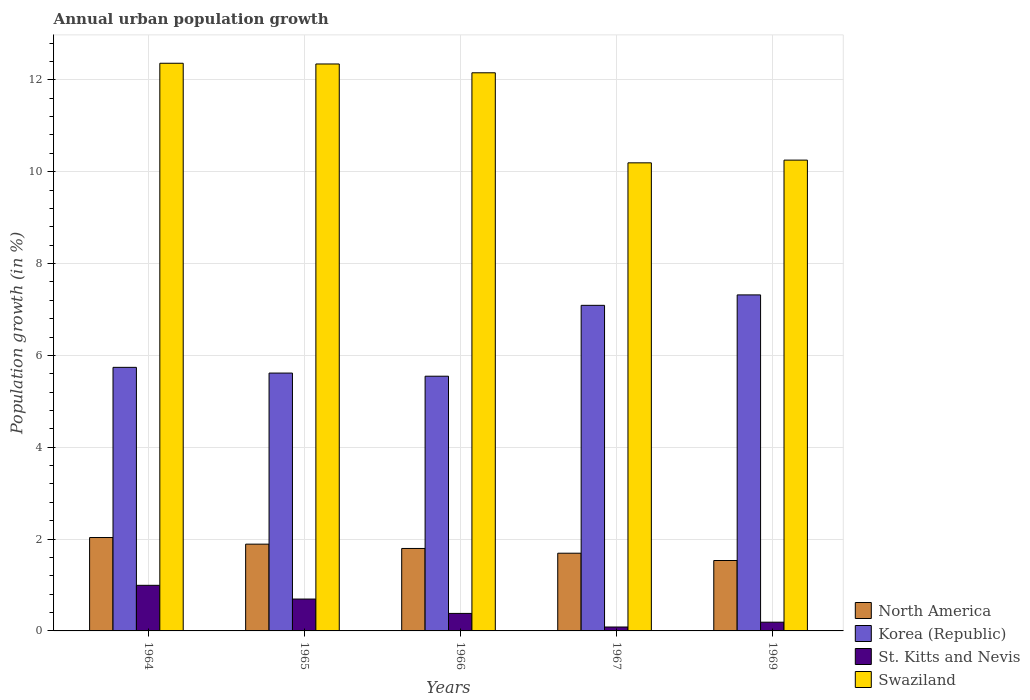How many groups of bars are there?
Ensure brevity in your answer.  5. How many bars are there on the 3rd tick from the right?
Your answer should be very brief. 4. What is the label of the 3rd group of bars from the left?
Offer a terse response. 1966. What is the percentage of urban population growth in St. Kitts and Nevis in 1966?
Ensure brevity in your answer.  0.38. Across all years, what is the maximum percentage of urban population growth in Swaziland?
Make the answer very short. 12.36. Across all years, what is the minimum percentage of urban population growth in North America?
Provide a succinct answer. 1.53. In which year was the percentage of urban population growth in St. Kitts and Nevis maximum?
Offer a terse response. 1964. In which year was the percentage of urban population growth in Swaziland minimum?
Give a very brief answer. 1967. What is the total percentage of urban population growth in North America in the graph?
Your answer should be compact. 8.94. What is the difference between the percentage of urban population growth in Swaziland in 1965 and that in 1969?
Your response must be concise. 2.09. What is the difference between the percentage of urban population growth in Swaziland in 1965 and the percentage of urban population growth in North America in 1967?
Your answer should be very brief. 10.65. What is the average percentage of urban population growth in North America per year?
Your answer should be compact. 1.79. In the year 1964, what is the difference between the percentage of urban population growth in Korea (Republic) and percentage of urban population growth in St. Kitts and Nevis?
Give a very brief answer. 4.75. What is the ratio of the percentage of urban population growth in St. Kitts and Nevis in 1967 to that in 1969?
Your response must be concise. 0.45. Is the difference between the percentage of urban population growth in Korea (Republic) in 1965 and 1966 greater than the difference between the percentage of urban population growth in St. Kitts and Nevis in 1965 and 1966?
Offer a terse response. No. What is the difference between the highest and the second highest percentage of urban population growth in Korea (Republic)?
Ensure brevity in your answer.  0.23. What is the difference between the highest and the lowest percentage of urban population growth in Korea (Republic)?
Offer a terse response. 1.77. Is the sum of the percentage of urban population growth in Swaziland in 1966 and 1969 greater than the maximum percentage of urban population growth in North America across all years?
Provide a short and direct response. Yes. Is it the case that in every year, the sum of the percentage of urban population growth in St. Kitts and Nevis and percentage of urban population growth in Swaziland is greater than the sum of percentage of urban population growth in Korea (Republic) and percentage of urban population growth in North America?
Keep it short and to the point. Yes. Is it the case that in every year, the sum of the percentage of urban population growth in Korea (Republic) and percentage of urban population growth in Swaziland is greater than the percentage of urban population growth in North America?
Give a very brief answer. Yes. Are all the bars in the graph horizontal?
Offer a very short reply. No. How many years are there in the graph?
Offer a very short reply. 5. Does the graph contain any zero values?
Give a very brief answer. No. Does the graph contain grids?
Your response must be concise. Yes. Where does the legend appear in the graph?
Provide a succinct answer. Bottom right. What is the title of the graph?
Your answer should be very brief. Annual urban population growth. What is the label or title of the Y-axis?
Provide a succinct answer. Population growth (in %). What is the Population growth (in %) in North America in 1964?
Make the answer very short. 2.03. What is the Population growth (in %) in Korea (Republic) in 1964?
Provide a succinct answer. 5.74. What is the Population growth (in %) in St. Kitts and Nevis in 1964?
Keep it short and to the point. 0.99. What is the Population growth (in %) of Swaziland in 1964?
Provide a short and direct response. 12.36. What is the Population growth (in %) in North America in 1965?
Your response must be concise. 1.89. What is the Population growth (in %) of Korea (Republic) in 1965?
Give a very brief answer. 5.62. What is the Population growth (in %) of St. Kitts and Nevis in 1965?
Offer a very short reply. 0.69. What is the Population growth (in %) of Swaziland in 1965?
Offer a terse response. 12.35. What is the Population growth (in %) of North America in 1966?
Your answer should be compact. 1.8. What is the Population growth (in %) of Korea (Republic) in 1966?
Offer a terse response. 5.55. What is the Population growth (in %) in St. Kitts and Nevis in 1966?
Give a very brief answer. 0.38. What is the Population growth (in %) of Swaziland in 1966?
Your answer should be compact. 12.15. What is the Population growth (in %) of North America in 1967?
Offer a terse response. 1.69. What is the Population growth (in %) in Korea (Republic) in 1967?
Your answer should be very brief. 7.09. What is the Population growth (in %) in St. Kitts and Nevis in 1967?
Your answer should be very brief. 0.09. What is the Population growth (in %) in Swaziland in 1967?
Your answer should be very brief. 10.19. What is the Population growth (in %) in North America in 1969?
Your answer should be very brief. 1.53. What is the Population growth (in %) in Korea (Republic) in 1969?
Your response must be concise. 7.32. What is the Population growth (in %) of St. Kitts and Nevis in 1969?
Provide a succinct answer. 0.19. What is the Population growth (in %) in Swaziland in 1969?
Offer a very short reply. 10.25. Across all years, what is the maximum Population growth (in %) of North America?
Your answer should be compact. 2.03. Across all years, what is the maximum Population growth (in %) in Korea (Republic)?
Offer a terse response. 7.32. Across all years, what is the maximum Population growth (in %) of St. Kitts and Nevis?
Offer a terse response. 0.99. Across all years, what is the maximum Population growth (in %) in Swaziland?
Provide a succinct answer. 12.36. Across all years, what is the minimum Population growth (in %) in North America?
Give a very brief answer. 1.53. Across all years, what is the minimum Population growth (in %) of Korea (Republic)?
Make the answer very short. 5.55. Across all years, what is the minimum Population growth (in %) in St. Kitts and Nevis?
Provide a short and direct response. 0.09. Across all years, what is the minimum Population growth (in %) in Swaziland?
Ensure brevity in your answer.  10.19. What is the total Population growth (in %) in North America in the graph?
Make the answer very short. 8.94. What is the total Population growth (in %) in Korea (Republic) in the graph?
Your response must be concise. 31.31. What is the total Population growth (in %) in St. Kitts and Nevis in the graph?
Your answer should be compact. 2.34. What is the total Population growth (in %) in Swaziland in the graph?
Provide a short and direct response. 57.31. What is the difference between the Population growth (in %) of North America in 1964 and that in 1965?
Make the answer very short. 0.14. What is the difference between the Population growth (in %) in Korea (Republic) in 1964 and that in 1965?
Your answer should be very brief. 0.12. What is the difference between the Population growth (in %) of St. Kitts and Nevis in 1964 and that in 1965?
Provide a succinct answer. 0.3. What is the difference between the Population growth (in %) in Swaziland in 1964 and that in 1965?
Your answer should be compact. 0.02. What is the difference between the Population growth (in %) of North America in 1964 and that in 1966?
Provide a succinct answer. 0.24. What is the difference between the Population growth (in %) in Korea (Republic) in 1964 and that in 1966?
Keep it short and to the point. 0.19. What is the difference between the Population growth (in %) of St. Kitts and Nevis in 1964 and that in 1966?
Offer a terse response. 0.61. What is the difference between the Population growth (in %) in Swaziland in 1964 and that in 1966?
Give a very brief answer. 0.21. What is the difference between the Population growth (in %) in North America in 1964 and that in 1967?
Your answer should be compact. 0.34. What is the difference between the Population growth (in %) of Korea (Republic) in 1964 and that in 1967?
Your answer should be compact. -1.35. What is the difference between the Population growth (in %) in St. Kitts and Nevis in 1964 and that in 1967?
Offer a very short reply. 0.91. What is the difference between the Population growth (in %) in Swaziland in 1964 and that in 1967?
Make the answer very short. 2.17. What is the difference between the Population growth (in %) in North America in 1964 and that in 1969?
Provide a succinct answer. 0.5. What is the difference between the Population growth (in %) of Korea (Republic) in 1964 and that in 1969?
Ensure brevity in your answer.  -1.58. What is the difference between the Population growth (in %) of St. Kitts and Nevis in 1964 and that in 1969?
Your answer should be compact. 0.8. What is the difference between the Population growth (in %) in Swaziland in 1964 and that in 1969?
Offer a terse response. 2.11. What is the difference between the Population growth (in %) in North America in 1965 and that in 1966?
Your answer should be compact. 0.09. What is the difference between the Population growth (in %) in Korea (Republic) in 1965 and that in 1966?
Offer a very short reply. 0.07. What is the difference between the Population growth (in %) in St. Kitts and Nevis in 1965 and that in 1966?
Your response must be concise. 0.31. What is the difference between the Population growth (in %) of Swaziland in 1965 and that in 1966?
Ensure brevity in your answer.  0.19. What is the difference between the Population growth (in %) of North America in 1965 and that in 1967?
Give a very brief answer. 0.2. What is the difference between the Population growth (in %) in Korea (Republic) in 1965 and that in 1967?
Keep it short and to the point. -1.48. What is the difference between the Population growth (in %) of St. Kitts and Nevis in 1965 and that in 1967?
Your answer should be compact. 0.61. What is the difference between the Population growth (in %) of Swaziland in 1965 and that in 1967?
Provide a succinct answer. 2.15. What is the difference between the Population growth (in %) in North America in 1965 and that in 1969?
Give a very brief answer. 0.36. What is the difference between the Population growth (in %) in Korea (Republic) in 1965 and that in 1969?
Ensure brevity in your answer.  -1.7. What is the difference between the Population growth (in %) of St. Kitts and Nevis in 1965 and that in 1969?
Your answer should be very brief. 0.5. What is the difference between the Population growth (in %) of Swaziland in 1965 and that in 1969?
Provide a short and direct response. 2.09. What is the difference between the Population growth (in %) in North America in 1966 and that in 1967?
Ensure brevity in your answer.  0.1. What is the difference between the Population growth (in %) of Korea (Republic) in 1966 and that in 1967?
Provide a succinct answer. -1.54. What is the difference between the Population growth (in %) in St. Kitts and Nevis in 1966 and that in 1967?
Your response must be concise. 0.3. What is the difference between the Population growth (in %) of Swaziland in 1966 and that in 1967?
Make the answer very short. 1.96. What is the difference between the Population growth (in %) in North America in 1966 and that in 1969?
Make the answer very short. 0.26. What is the difference between the Population growth (in %) in Korea (Republic) in 1966 and that in 1969?
Ensure brevity in your answer.  -1.77. What is the difference between the Population growth (in %) of St. Kitts and Nevis in 1966 and that in 1969?
Keep it short and to the point. 0.19. What is the difference between the Population growth (in %) in Swaziland in 1966 and that in 1969?
Your response must be concise. 1.9. What is the difference between the Population growth (in %) of North America in 1967 and that in 1969?
Make the answer very short. 0.16. What is the difference between the Population growth (in %) of Korea (Republic) in 1967 and that in 1969?
Keep it short and to the point. -0.23. What is the difference between the Population growth (in %) of St. Kitts and Nevis in 1967 and that in 1969?
Provide a short and direct response. -0.1. What is the difference between the Population growth (in %) in Swaziland in 1967 and that in 1969?
Your answer should be very brief. -0.06. What is the difference between the Population growth (in %) in North America in 1964 and the Population growth (in %) in Korea (Republic) in 1965?
Provide a short and direct response. -3.58. What is the difference between the Population growth (in %) of North America in 1964 and the Population growth (in %) of St. Kitts and Nevis in 1965?
Offer a very short reply. 1.34. What is the difference between the Population growth (in %) of North America in 1964 and the Population growth (in %) of Swaziland in 1965?
Provide a short and direct response. -10.31. What is the difference between the Population growth (in %) of Korea (Republic) in 1964 and the Population growth (in %) of St. Kitts and Nevis in 1965?
Make the answer very short. 5.05. What is the difference between the Population growth (in %) in Korea (Republic) in 1964 and the Population growth (in %) in Swaziland in 1965?
Your response must be concise. -6.61. What is the difference between the Population growth (in %) of St. Kitts and Nevis in 1964 and the Population growth (in %) of Swaziland in 1965?
Ensure brevity in your answer.  -11.35. What is the difference between the Population growth (in %) in North America in 1964 and the Population growth (in %) in Korea (Republic) in 1966?
Give a very brief answer. -3.51. What is the difference between the Population growth (in %) in North America in 1964 and the Population growth (in %) in St. Kitts and Nevis in 1966?
Your response must be concise. 1.65. What is the difference between the Population growth (in %) in North America in 1964 and the Population growth (in %) in Swaziland in 1966?
Give a very brief answer. -10.12. What is the difference between the Population growth (in %) in Korea (Republic) in 1964 and the Population growth (in %) in St. Kitts and Nevis in 1966?
Your response must be concise. 5.36. What is the difference between the Population growth (in %) of Korea (Republic) in 1964 and the Population growth (in %) of Swaziland in 1966?
Offer a very short reply. -6.41. What is the difference between the Population growth (in %) of St. Kitts and Nevis in 1964 and the Population growth (in %) of Swaziland in 1966?
Make the answer very short. -11.16. What is the difference between the Population growth (in %) in North America in 1964 and the Population growth (in %) in Korea (Republic) in 1967?
Offer a terse response. -5.06. What is the difference between the Population growth (in %) of North America in 1964 and the Population growth (in %) of St. Kitts and Nevis in 1967?
Your answer should be compact. 1.95. What is the difference between the Population growth (in %) of North America in 1964 and the Population growth (in %) of Swaziland in 1967?
Give a very brief answer. -8.16. What is the difference between the Population growth (in %) of Korea (Republic) in 1964 and the Population growth (in %) of St. Kitts and Nevis in 1967?
Provide a short and direct response. 5.65. What is the difference between the Population growth (in %) of Korea (Republic) in 1964 and the Population growth (in %) of Swaziland in 1967?
Ensure brevity in your answer.  -4.45. What is the difference between the Population growth (in %) in St. Kitts and Nevis in 1964 and the Population growth (in %) in Swaziland in 1967?
Your answer should be very brief. -9.2. What is the difference between the Population growth (in %) in North America in 1964 and the Population growth (in %) in Korea (Republic) in 1969?
Offer a terse response. -5.28. What is the difference between the Population growth (in %) in North America in 1964 and the Population growth (in %) in St. Kitts and Nevis in 1969?
Keep it short and to the point. 1.84. What is the difference between the Population growth (in %) of North America in 1964 and the Population growth (in %) of Swaziland in 1969?
Provide a short and direct response. -8.22. What is the difference between the Population growth (in %) of Korea (Republic) in 1964 and the Population growth (in %) of St. Kitts and Nevis in 1969?
Your response must be concise. 5.55. What is the difference between the Population growth (in %) in Korea (Republic) in 1964 and the Population growth (in %) in Swaziland in 1969?
Offer a very short reply. -4.51. What is the difference between the Population growth (in %) in St. Kitts and Nevis in 1964 and the Population growth (in %) in Swaziland in 1969?
Your answer should be very brief. -9.26. What is the difference between the Population growth (in %) of North America in 1965 and the Population growth (in %) of Korea (Republic) in 1966?
Provide a succinct answer. -3.66. What is the difference between the Population growth (in %) of North America in 1965 and the Population growth (in %) of St. Kitts and Nevis in 1966?
Offer a very short reply. 1.51. What is the difference between the Population growth (in %) of North America in 1965 and the Population growth (in %) of Swaziland in 1966?
Offer a terse response. -10.26. What is the difference between the Population growth (in %) in Korea (Republic) in 1965 and the Population growth (in %) in St. Kitts and Nevis in 1966?
Provide a short and direct response. 5.23. What is the difference between the Population growth (in %) in Korea (Republic) in 1965 and the Population growth (in %) in Swaziland in 1966?
Provide a short and direct response. -6.54. What is the difference between the Population growth (in %) in St. Kitts and Nevis in 1965 and the Population growth (in %) in Swaziland in 1966?
Offer a terse response. -11.46. What is the difference between the Population growth (in %) of North America in 1965 and the Population growth (in %) of Korea (Republic) in 1967?
Keep it short and to the point. -5.2. What is the difference between the Population growth (in %) in North America in 1965 and the Population growth (in %) in St. Kitts and Nevis in 1967?
Offer a terse response. 1.8. What is the difference between the Population growth (in %) of North America in 1965 and the Population growth (in %) of Swaziland in 1967?
Provide a short and direct response. -8.3. What is the difference between the Population growth (in %) of Korea (Republic) in 1965 and the Population growth (in %) of St. Kitts and Nevis in 1967?
Your answer should be compact. 5.53. What is the difference between the Population growth (in %) of Korea (Republic) in 1965 and the Population growth (in %) of Swaziland in 1967?
Your answer should be compact. -4.58. What is the difference between the Population growth (in %) of St. Kitts and Nevis in 1965 and the Population growth (in %) of Swaziland in 1967?
Provide a short and direct response. -9.5. What is the difference between the Population growth (in %) of North America in 1965 and the Population growth (in %) of Korea (Republic) in 1969?
Offer a terse response. -5.43. What is the difference between the Population growth (in %) in North America in 1965 and the Population growth (in %) in St. Kitts and Nevis in 1969?
Offer a very short reply. 1.7. What is the difference between the Population growth (in %) in North America in 1965 and the Population growth (in %) in Swaziland in 1969?
Offer a very short reply. -8.36. What is the difference between the Population growth (in %) of Korea (Republic) in 1965 and the Population growth (in %) of St. Kitts and Nevis in 1969?
Provide a short and direct response. 5.43. What is the difference between the Population growth (in %) of Korea (Republic) in 1965 and the Population growth (in %) of Swaziland in 1969?
Offer a terse response. -4.64. What is the difference between the Population growth (in %) in St. Kitts and Nevis in 1965 and the Population growth (in %) in Swaziland in 1969?
Make the answer very short. -9.56. What is the difference between the Population growth (in %) in North America in 1966 and the Population growth (in %) in Korea (Republic) in 1967?
Give a very brief answer. -5.29. What is the difference between the Population growth (in %) in North America in 1966 and the Population growth (in %) in St. Kitts and Nevis in 1967?
Give a very brief answer. 1.71. What is the difference between the Population growth (in %) in North America in 1966 and the Population growth (in %) in Swaziland in 1967?
Your answer should be very brief. -8.4. What is the difference between the Population growth (in %) of Korea (Republic) in 1966 and the Population growth (in %) of St. Kitts and Nevis in 1967?
Your response must be concise. 5.46. What is the difference between the Population growth (in %) in Korea (Republic) in 1966 and the Population growth (in %) in Swaziland in 1967?
Your answer should be compact. -4.65. What is the difference between the Population growth (in %) of St. Kitts and Nevis in 1966 and the Population growth (in %) of Swaziland in 1967?
Your response must be concise. -9.81. What is the difference between the Population growth (in %) of North America in 1966 and the Population growth (in %) of Korea (Republic) in 1969?
Your response must be concise. -5.52. What is the difference between the Population growth (in %) in North America in 1966 and the Population growth (in %) in St. Kitts and Nevis in 1969?
Provide a short and direct response. 1.61. What is the difference between the Population growth (in %) in North America in 1966 and the Population growth (in %) in Swaziland in 1969?
Make the answer very short. -8.46. What is the difference between the Population growth (in %) in Korea (Republic) in 1966 and the Population growth (in %) in St. Kitts and Nevis in 1969?
Keep it short and to the point. 5.36. What is the difference between the Population growth (in %) in Korea (Republic) in 1966 and the Population growth (in %) in Swaziland in 1969?
Your answer should be compact. -4.71. What is the difference between the Population growth (in %) in St. Kitts and Nevis in 1966 and the Population growth (in %) in Swaziland in 1969?
Provide a succinct answer. -9.87. What is the difference between the Population growth (in %) of North America in 1967 and the Population growth (in %) of Korea (Republic) in 1969?
Your response must be concise. -5.62. What is the difference between the Population growth (in %) of North America in 1967 and the Population growth (in %) of St. Kitts and Nevis in 1969?
Ensure brevity in your answer.  1.5. What is the difference between the Population growth (in %) in North America in 1967 and the Population growth (in %) in Swaziland in 1969?
Keep it short and to the point. -8.56. What is the difference between the Population growth (in %) of Korea (Republic) in 1967 and the Population growth (in %) of St. Kitts and Nevis in 1969?
Provide a succinct answer. 6.9. What is the difference between the Population growth (in %) in Korea (Republic) in 1967 and the Population growth (in %) in Swaziland in 1969?
Your answer should be very brief. -3.16. What is the difference between the Population growth (in %) in St. Kitts and Nevis in 1967 and the Population growth (in %) in Swaziland in 1969?
Offer a terse response. -10.17. What is the average Population growth (in %) in North America per year?
Your answer should be very brief. 1.79. What is the average Population growth (in %) of Korea (Republic) per year?
Your answer should be compact. 6.26. What is the average Population growth (in %) of St. Kitts and Nevis per year?
Provide a succinct answer. 0.47. What is the average Population growth (in %) in Swaziland per year?
Make the answer very short. 11.46. In the year 1964, what is the difference between the Population growth (in %) in North America and Population growth (in %) in Korea (Republic)?
Provide a succinct answer. -3.71. In the year 1964, what is the difference between the Population growth (in %) of North America and Population growth (in %) of St. Kitts and Nevis?
Provide a short and direct response. 1.04. In the year 1964, what is the difference between the Population growth (in %) of North America and Population growth (in %) of Swaziland?
Offer a very short reply. -10.33. In the year 1964, what is the difference between the Population growth (in %) of Korea (Republic) and Population growth (in %) of St. Kitts and Nevis?
Offer a very short reply. 4.75. In the year 1964, what is the difference between the Population growth (in %) of Korea (Republic) and Population growth (in %) of Swaziland?
Keep it short and to the point. -6.62. In the year 1964, what is the difference between the Population growth (in %) of St. Kitts and Nevis and Population growth (in %) of Swaziland?
Make the answer very short. -11.37. In the year 1965, what is the difference between the Population growth (in %) in North America and Population growth (in %) in Korea (Republic)?
Your answer should be compact. -3.73. In the year 1965, what is the difference between the Population growth (in %) of North America and Population growth (in %) of St. Kitts and Nevis?
Offer a very short reply. 1.2. In the year 1965, what is the difference between the Population growth (in %) in North America and Population growth (in %) in Swaziland?
Provide a short and direct response. -10.46. In the year 1965, what is the difference between the Population growth (in %) of Korea (Republic) and Population growth (in %) of St. Kitts and Nevis?
Offer a terse response. 4.92. In the year 1965, what is the difference between the Population growth (in %) in Korea (Republic) and Population growth (in %) in Swaziland?
Give a very brief answer. -6.73. In the year 1965, what is the difference between the Population growth (in %) in St. Kitts and Nevis and Population growth (in %) in Swaziland?
Provide a short and direct response. -11.65. In the year 1966, what is the difference between the Population growth (in %) in North America and Population growth (in %) in Korea (Republic)?
Your response must be concise. -3.75. In the year 1966, what is the difference between the Population growth (in %) of North America and Population growth (in %) of St. Kitts and Nevis?
Offer a very short reply. 1.41. In the year 1966, what is the difference between the Population growth (in %) of North America and Population growth (in %) of Swaziland?
Your response must be concise. -10.36. In the year 1966, what is the difference between the Population growth (in %) in Korea (Republic) and Population growth (in %) in St. Kitts and Nevis?
Your answer should be compact. 5.17. In the year 1966, what is the difference between the Population growth (in %) of Korea (Republic) and Population growth (in %) of Swaziland?
Keep it short and to the point. -6.61. In the year 1966, what is the difference between the Population growth (in %) of St. Kitts and Nevis and Population growth (in %) of Swaziland?
Offer a terse response. -11.77. In the year 1967, what is the difference between the Population growth (in %) in North America and Population growth (in %) in Korea (Republic)?
Keep it short and to the point. -5.4. In the year 1967, what is the difference between the Population growth (in %) of North America and Population growth (in %) of St. Kitts and Nevis?
Make the answer very short. 1.61. In the year 1967, what is the difference between the Population growth (in %) in North America and Population growth (in %) in Swaziland?
Provide a short and direct response. -8.5. In the year 1967, what is the difference between the Population growth (in %) in Korea (Republic) and Population growth (in %) in St. Kitts and Nevis?
Give a very brief answer. 7. In the year 1967, what is the difference between the Population growth (in %) in Korea (Republic) and Population growth (in %) in Swaziland?
Offer a terse response. -3.1. In the year 1967, what is the difference between the Population growth (in %) in St. Kitts and Nevis and Population growth (in %) in Swaziland?
Provide a succinct answer. -10.11. In the year 1969, what is the difference between the Population growth (in %) of North America and Population growth (in %) of Korea (Republic)?
Ensure brevity in your answer.  -5.78. In the year 1969, what is the difference between the Population growth (in %) of North America and Population growth (in %) of St. Kitts and Nevis?
Provide a succinct answer. 1.34. In the year 1969, what is the difference between the Population growth (in %) in North America and Population growth (in %) in Swaziland?
Your response must be concise. -8.72. In the year 1969, what is the difference between the Population growth (in %) in Korea (Republic) and Population growth (in %) in St. Kitts and Nevis?
Make the answer very short. 7.13. In the year 1969, what is the difference between the Population growth (in %) in Korea (Republic) and Population growth (in %) in Swaziland?
Give a very brief answer. -2.94. In the year 1969, what is the difference between the Population growth (in %) of St. Kitts and Nevis and Population growth (in %) of Swaziland?
Give a very brief answer. -10.06. What is the ratio of the Population growth (in %) of North America in 1964 to that in 1965?
Keep it short and to the point. 1.08. What is the ratio of the Population growth (in %) of Korea (Republic) in 1964 to that in 1965?
Your response must be concise. 1.02. What is the ratio of the Population growth (in %) of St. Kitts and Nevis in 1964 to that in 1965?
Your response must be concise. 1.43. What is the ratio of the Population growth (in %) in North America in 1964 to that in 1966?
Offer a very short reply. 1.13. What is the ratio of the Population growth (in %) in Korea (Republic) in 1964 to that in 1966?
Provide a short and direct response. 1.03. What is the ratio of the Population growth (in %) of St. Kitts and Nevis in 1964 to that in 1966?
Provide a succinct answer. 2.6. What is the ratio of the Population growth (in %) in Swaziland in 1964 to that in 1966?
Offer a terse response. 1.02. What is the ratio of the Population growth (in %) of North America in 1964 to that in 1967?
Provide a short and direct response. 1.2. What is the ratio of the Population growth (in %) of Korea (Republic) in 1964 to that in 1967?
Give a very brief answer. 0.81. What is the ratio of the Population growth (in %) in St. Kitts and Nevis in 1964 to that in 1967?
Your answer should be compact. 11.65. What is the ratio of the Population growth (in %) of Swaziland in 1964 to that in 1967?
Your answer should be compact. 1.21. What is the ratio of the Population growth (in %) of North America in 1964 to that in 1969?
Offer a terse response. 1.33. What is the ratio of the Population growth (in %) in Korea (Republic) in 1964 to that in 1969?
Ensure brevity in your answer.  0.78. What is the ratio of the Population growth (in %) in St. Kitts and Nevis in 1964 to that in 1969?
Your answer should be very brief. 5.23. What is the ratio of the Population growth (in %) of Swaziland in 1964 to that in 1969?
Give a very brief answer. 1.21. What is the ratio of the Population growth (in %) of North America in 1965 to that in 1966?
Keep it short and to the point. 1.05. What is the ratio of the Population growth (in %) in Korea (Republic) in 1965 to that in 1966?
Make the answer very short. 1.01. What is the ratio of the Population growth (in %) in St. Kitts and Nevis in 1965 to that in 1966?
Ensure brevity in your answer.  1.82. What is the ratio of the Population growth (in %) in Swaziland in 1965 to that in 1966?
Provide a short and direct response. 1.02. What is the ratio of the Population growth (in %) of North America in 1965 to that in 1967?
Keep it short and to the point. 1.12. What is the ratio of the Population growth (in %) of Korea (Republic) in 1965 to that in 1967?
Provide a succinct answer. 0.79. What is the ratio of the Population growth (in %) of St. Kitts and Nevis in 1965 to that in 1967?
Make the answer very short. 8.14. What is the ratio of the Population growth (in %) of Swaziland in 1965 to that in 1967?
Offer a terse response. 1.21. What is the ratio of the Population growth (in %) of North America in 1965 to that in 1969?
Keep it short and to the point. 1.23. What is the ratio of the Population growth (in %) of Korea (Republic) in 1965 to that in 1969?
Offer a very short reply. 0.77. What is the ratio of the Population growth (in %) in St. Kitts and Nevis in 1965 to that in 1969?
Provide a succinct answer. 3.65. What is the ratio of the Population growth (in %) in Swaziland in 1965 to that in 1969?
Provide a short and direct response. 1.2. What is the ratio of the Population growth (in %) in North America in 1966 to that in 1967?
Make the answer very short. 1.06. What is the ratio of the Population growth (in %) in Korea (Republic) in 1966 to that in 1967?
Offer a very short reply. 0.78. What is the ratio of the Population growth (in %) in St. Kitts and Nevis in 1966 to that in 1967?
Your answer should be compact. 4.47. What is the ratio of the Population growth (in %) in Swaziland in 1966 to that in 1967?
Provide a succinct answer. 1.19. What is the ratio of the Population growth (in %) in North America in 1966 to that in 1969?
Your answer should be very brief. 1.17. What is the ratio of the Population growth (in %) in Korea (Republic) in 1966 to that in 1969?
Give a very brief answer. 0.76. What is the ratio of the Population growth (in %) of St. Kitts and Nevis in 1966 to that in 1969?
Provide a succinct answer. 2.01. What is the ratio of the Population growth (in %) of Swaziland in 1966 to that in 1969?
Provide a short and direct response. 1.19. What is the ratio of the Population growth (in %) in North America in 1967 to that in 1969?
Give a very brief answer. 1.1. What is the ratio of the Population growth (in %) in St. Kitts and Nevis in 1967 to that in 1969?
Keep it short and to the point. 0.45. What is the ratio of the Population growth (in %) of Swaziland in 1967 to that in 1969?
Give a very brief answer. 0.99. What is the difference between the highest and the second highest Population growth (in %) in North America?
Your answer should be compact. 0.14. What is the difference between the highest and the second highest Population growth (in %) of Korea (Republic)?
Ensure brevity in your answer.  0.23. What is the difference between the highest and the second highest Population growth (in %) of St. Kitts and Nevis?
Provide a short and direct response. 0.3. What is the difference between the highest and the second highest Population growth (in %) of Swaziland?
Keep it short and to the point. 0.02. What is the difference between the highest and the lowest Population growth (in %) in North America?
Your answer should be compact. 0.5. What is the difference between the highest and the lowest Population growth (in %) of Korea (Republic)?
Offer a very short reply. 1.77. What is the difference between the highest and the lowest Population growth (in %) in St. Kitts and Nevis?
Ensure brevity in your answer.  0.91. What is the difference between the highest and the lowest Population growth (in %) of Swaziland?
Your answer should be very brief. 2.17. 